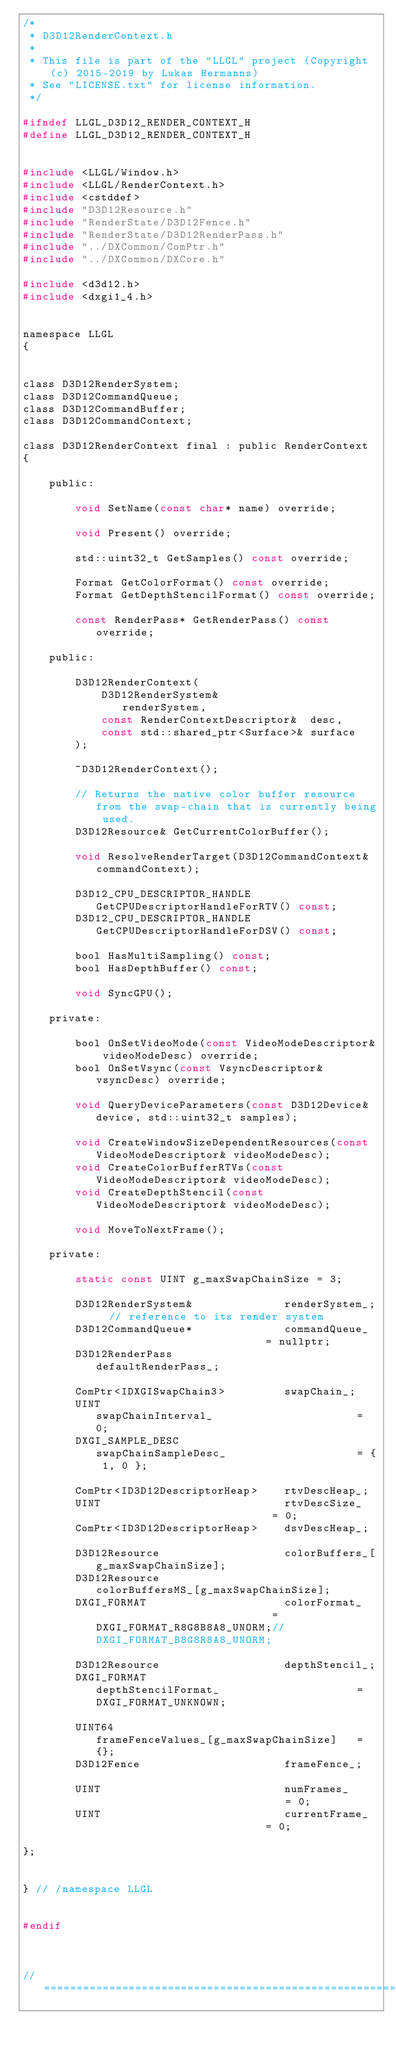<code> <loc_0><loc_0><loc_500><loc_500><_C_>/*
 * D3D12RenderContext.h
 * 
 * This file is part of the "LLGL" project (Copyright (c) 2015-2019 by Lukas Hermanns)
 * See "LICENSE.txt" for license information.
 */

#ifndef LLGL_D3D12_RENDER_CONTEXT_H
#define LLGL_D3D12_RENDER_CONTEXT_H


#include <LLGL/Window.h>
#include <LLGL/RenderContext.h>
#include <cstddef>
#include "D3D12Resource.h"
#include "RenderState/D3D12Fence.h"
#include "RenderState/D3D12RenderPass.h"
#include "../DXCommon/ComPtr.h"
#include "../DXCommon/DXCore.h"

#include <d3d12.h>
#include <dxgi1_4.h>


namespace LLGL
{


class D3D12RenderSystem;
class D3D12CommandQueue;
class D3D12CommandBuffer;
class D3D12CommandContext;

class D3D12RenderContext final : public RenderContext
{

    public:

        void SetName(const char* name) override;

        void Present() override;

        std::uint32_t GetSamples() const override;

        Format GetColorFormat() const override;
        Format GetDepthStencilFormat() const override;

        const RenderPass* GetRenderPass() const override;

    public:

        D3D12RenderContext(
            D3D12RenderSystem&              renderSystem,
            const RenderContextDescriptor&  desc,
            const std::shared_ptr<Surface>& surface
        );

        ~D3D12RenderContext();

        // Returns the native color buffer resource from the swap-chain that is currently being used.
        D3D12Resource& GetCurrentColorBuffer();

        void ResolveRenderTarget(D3D12CommandContext& commandContext);

        D3D12_CPU_DESCRIPTOR_HANDLE GetCPUDescriptorHandleForRTV() const;
        D3D12_CPU_DESCRIPTOR_HANDLE GetCPUDescriptorHandleForDSV() const;

        bool HasMultiSampling() const;
        bool HasDepthBuffer() const;

        void SyncGPU();

    private:

        bool OnSetVideoMode(const VideoModeDescriptor& videoModeDesc) override;
        bool OnSetVsync(const VsyncDescriptor& vsyncDesc) override;

        void QueryDeviceParameters(const D3D12Device& device, std::uint32_t samples);

        void CreateWindowSizeDependentResources(const VideoModeDescriptor& videoModeDesc);
        void CreateColorBufferRTVs(const VideoModeDescriptor& videoModeDesc);
        void CreateDepthStencil(const VideoModeDescriptor& videoModeDesc);

        void MoveToNextFrame();

    private:

        static const UINT g_maxSwapChainSize = 3;

        D3D12RenderSystem&              renderSystem_;  // reference to its render system
        D3D12CommandQueue*              commandQueue_                           = nullptr;
        D3D12RenderPass                 defaultRenderPass_;

        ComPtr<IDXGISwapChain3>         swapChain_;
        UINT                            swapChainInterval_                      = 0;
        DXGI_SAMPLE_DESC                swapChainSampleDesc_                    = { 1, 0 };

        ComPtr<ID3D12DescriptorHeap>    rtvDescHeap_;
        UINT                            rtvDescSize_                            = 0;
        ComPtr<ID3D12DescriptorHeap>    dsvDescHeap_;

        D3D12Resource                   colorBuffers_[g_maxSwapChainSize];
        D3D12Resource                   colorBuffersMS_[g_maxSwapChainSize];
        DXGI_FORMAT                     colorFormat_                            = DXGI_FORMAT_R8G8B8A8_UNORM;//DXGI_FORMAT_B8G8R8A8_UNORM;

        D3D12Resource                   depthStencil_;
        DXGI_FORMAT                     depthStencilFormat_                     = DXGI_FORMAT_UNKNOWN;

        UINT64                          frameFenceValues_[g_maxSwapChainSize]   = {};
        D3D12Fence                      frameFence_;

        UINT                            numFrames_                              = 0;
        UINT                            currentFrame_                           = 0;

};


} // /namespace LLGL


#endif



// ================================================================================
</code> 